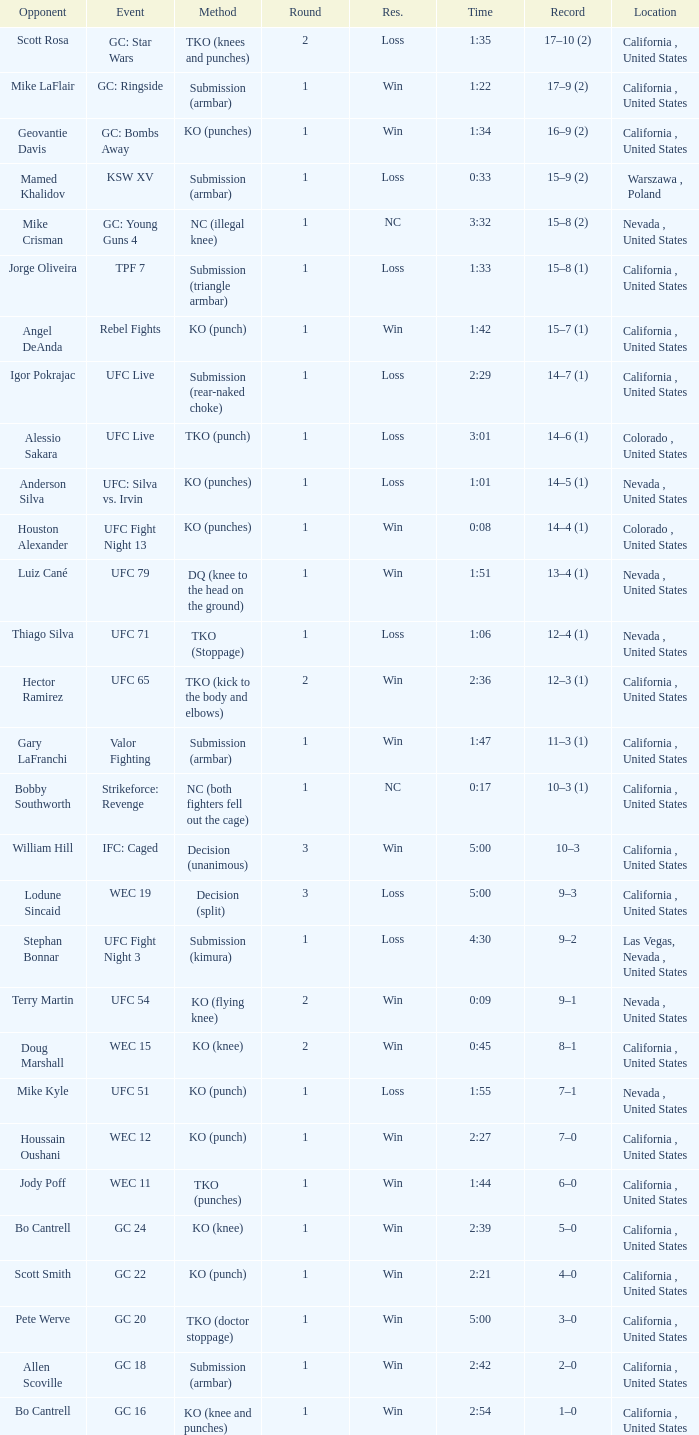What is the method where there is a loss with time 5:00? Decision (split). 